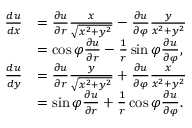<formula> <loc_0><loc_0><loc_500><loc_500>{ \begin{array} { r l } { { \frac { d u } { d x } } } & { = { \frac { \partial u } { \partial r } } { \frac { x } { \sqrt { x ^ { 2 } + y ^ { 2 } } } } - { \frac { \partial u } { \partial \varphi } } { \frac { y } { x ^ { 2 } + y ^ { 2 } } } } \\ & { = \cos \varphi { \frac { \partial u } { \partial r } } - { \frac { 1 } { r } } \sin \varphi { \frac { \partial u } { \partial \varphi } } , } \\ { { \frac { d u } { d y } } } & { = { \frac { \partial u } { \partial r } } { \frac { y } { \sqrt { x ^ { 2 } + y ^ { 2 } } } } + { \frac { \partial u } { \partial \varphi } } { \frac { x } { x ^ { 2 } + y ^ { 2 } } } } \\ & { = \sin \varphi { \frac { \partial u } { \partial r } } + { \frac { 1 } { r } } \cos \varphi { \frac { \partial u } { \partial \varphi } } . } \end{array} }</formula> 